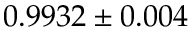Convert formula to latex. <formula><loc_0><loc_0><loc_500><loc_500>0 . 9 9 3 2 \pm 0 . 0 0 4</formula> 